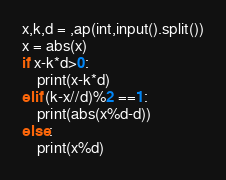<code> <loc_0><loc_0><loc_500><loc_500><_Python_>x,k,d = ,ap(int,input().split())
x = abs(x)
if x-k*d>0:
    print(x-k*d)
elif (k-x//d)%2 ==1:
    print(abs(x%d-d))
else:
    print(x%d)</code> 